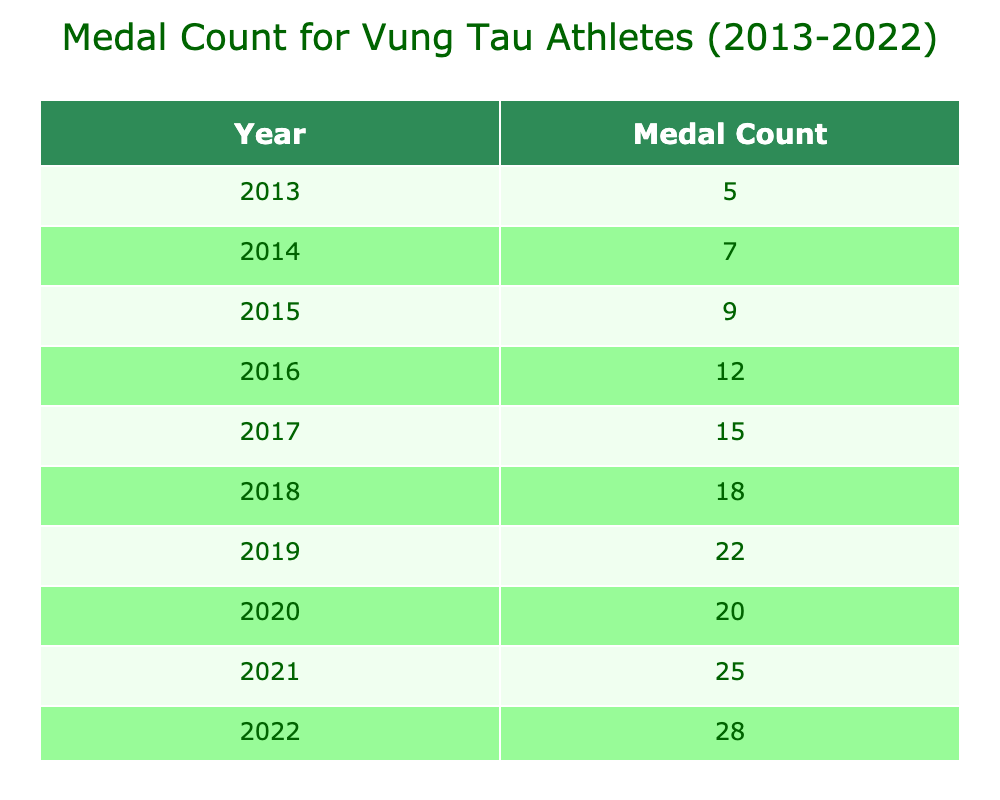What was the medal count in 2015? According to the table, the medal count for 2015 is listed as 9.
Answer: 9 What year had the highest medal count? From the table, the highest medal count is in 2022, which is 28.
Answer: 2022 How many medals were won by Vung Tau athletes in total from 2013 to 2022? To find the total, we add the medal counts: 5 + 7 + 9 + 12 + 15 + 18 + 22 + 20 + 25 + 28 = 141.
Answer: 141 What is the increase in medal count from 2013 to 2022? We find the difference between the medal counts for 2022 and 2013: 28 - 5 = 23.
Answer: 23 Was the medal count in 2020 higher than in 2019? By comparing the counts, 20 (in 2020) is less than 22 (in 2019), so the answer is no.
Answer: No What is the average medal count per year between 2013 and 2022? There are 10 years in total; we first sum the medal counts (141) and then divide by 10: 141 / 10 = 14.1.
Answer: 14.1 In which year did the medal count first exceed 15? Looking at the table, the first year where the count exceeds 15 is 2017, which has a count of 15.
Answer: 2017 How many more medals were won in 2021 compared to 2014? The counts are 25 for 2021 and 7 for 2014. The difference is 25 - 7 = 18.
Answer: 18 What pattern can be observed in the medal counts from 2013 to 2022? The medal counts consistently increased each year without any decline, suggesting a positive trend in performance.
Answer: Consistent increase How many years had a medal count of 20 or more? From the table, the years with counts of 20 or more are 2019 (22), 2020 (20), 2021 (25), and 2022 (28). This totals 4 years.
Answer: 4 